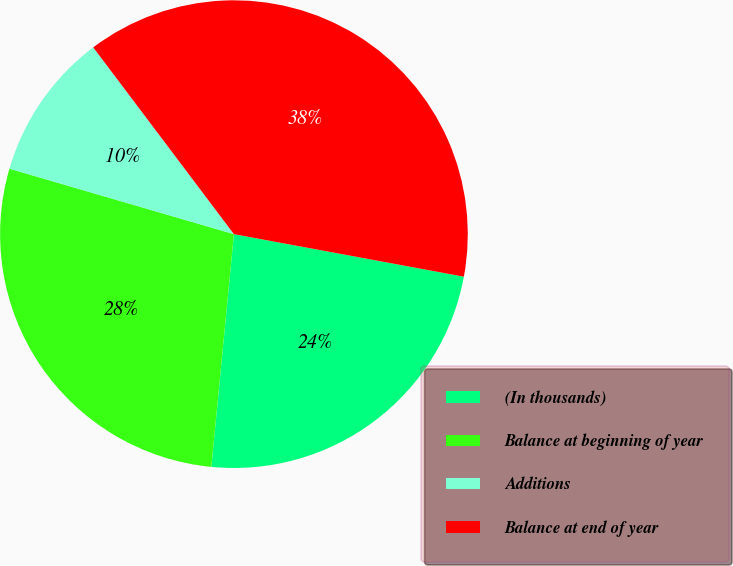Convert chart. <chart><loc_0><loc_0><loc_500><loc_500><pie_chart><fcel>(In thousands)<fcel>Balance at beginning of year<fcel>Additions<fcel>Balance at end of year<nl><fcel>23.63%<fcel>27.98%<fcel>10.21%<fcel>38.19%<nl></chart> 